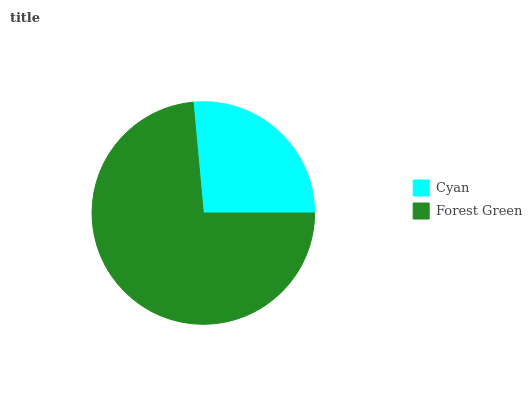Is Cyan the minimum?
Answer yes or no. Yes. Is Forest Green the maximum?
Answer yes or no. Yes. Is Forest Green the minimum?
Answer yes or no. No. Is Forest Green greater than Cyan?
Answer yes or no. Yes. Is Cyan less than Forest Green?
Answer yes or no. Yes. Is Cyan greater than Forest Green?
Answer yes or no. No. Is Forest Green less than Cyan?
Answer yes or no. No. Is Forest Green the high median?
Answer yes or no. Yes. Is Cyan the low median?
Answer yes or no. Yes. Is Cyan the high median?
Answer yes or no. No. Is Forest Green the low median?
Answer yes or no. No. 